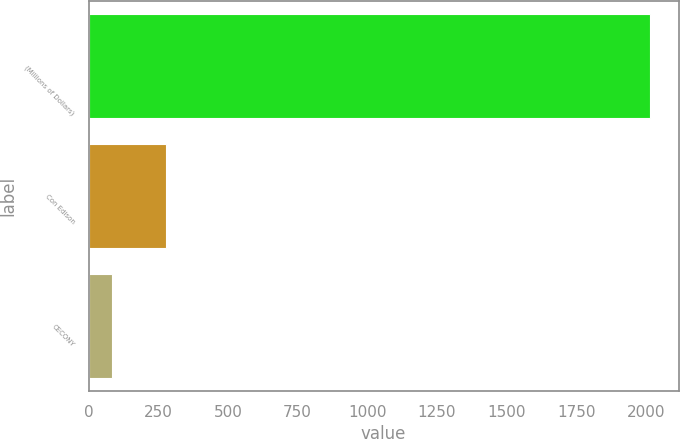Convert chart. <chart><loc_0><loc_0><loc_500><loc_500><bar_chart><fcel>(Millions of Dollars)<fcel>Con Edison<fcel>CECONY<nl><fcel>2017<fcel>276.4<fcel>83<nl></chart> 